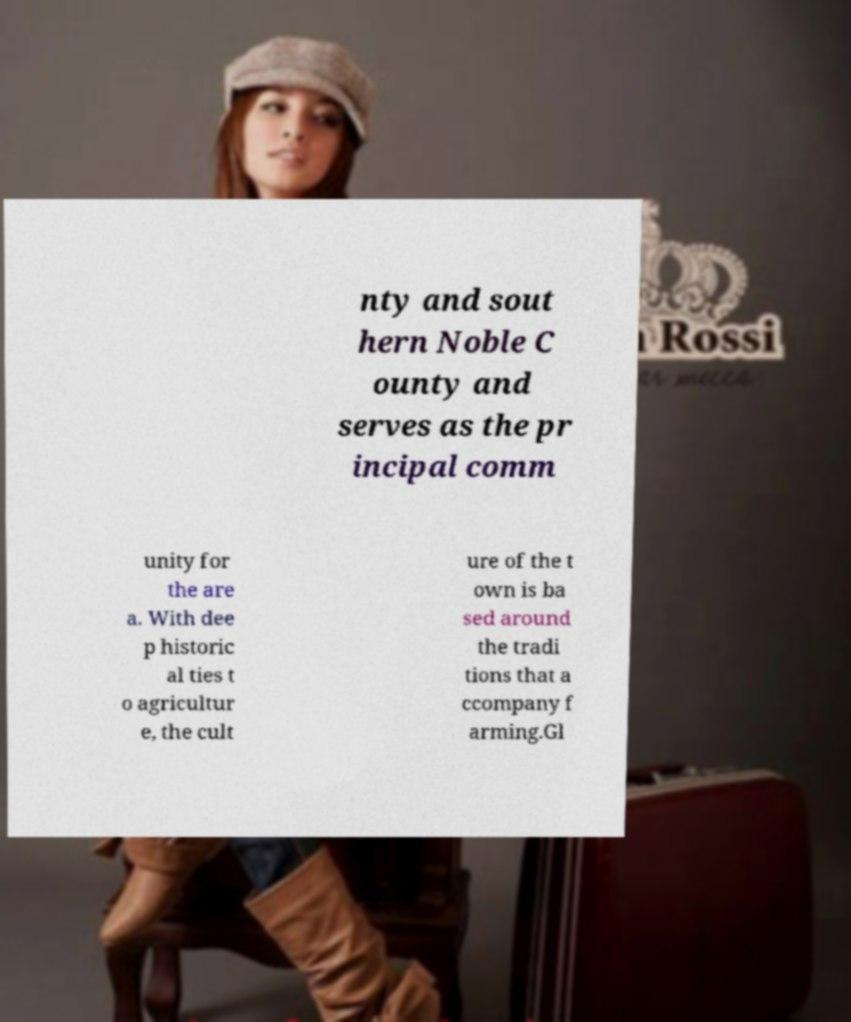Could you extract and type out the text from this image? nty and sout hern Noble C ounty and serves as the pr incipal comm unity for the are a. With dee p historic al ties t o agricultur e, the cult ure of the t own is ba sed around the tradi tions that a ccompany f arming.Gl 